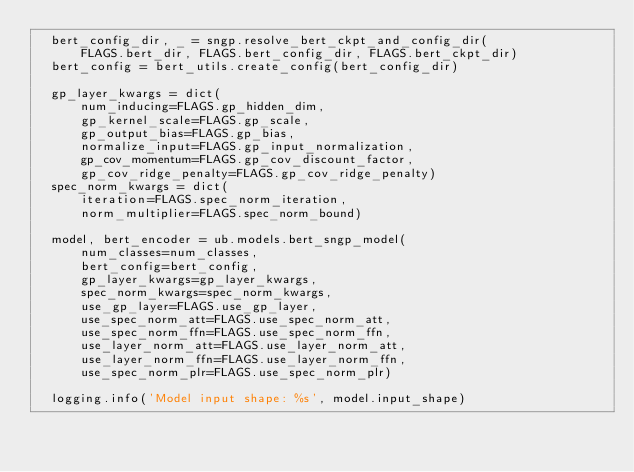Convert code to text. <code><loc_0><loc_0><loc_500><loc_500><_Python_>  bert_config_dir, _ = sngp.resolve_bert_ckpt_and_config_dir(
      FLAGS.bert_dir, FLAGS.bert_config_dir, FLAGS.bert_ckpt_dir)
  bert_config = bert_utils.create_config(bert_config_dir)

  gp_layer_kwargs = dict(
      num_inducing=FLAGS.gp_hidden_dim,
      gp_kernel_scale=FLAGS.gp_scale,
      gp_output_bias=FLAGS.gp_bias,
      normalize_input=FLAGS.gp_input_normalization,
      gp_cov_momentum=FLAGS.gp_cov_discount_factor,
      gp_cov_ridge_penalty=FLAGS.gp_cov_ridge_penalty)
  spec_norm_kwargs = dict(
      iteration=FLAGS.spec_norm_iteration,
      norm_multiplier=FLAGS.spec_norm_bound)

  model, bert_encoder = ub.models.bert_sngp_model(
      num_classes=num_classes,
      bert_config=bert_config,
      gp_layer_kwargs=gp_layer_kwargs,
      spec_norm_kwargs=spec_norm_kwargs,
      use_gp_layer=FLAGS.use_gp_layer,
      use_spec_norm_att=FLAGS.use_spec_norm_att,
      use_spec_norm_ffn=FLAGS.use_spec_norm_ffn,
      use_layer_norm_att=FLAGS.use_layer_norm_att,
      use_layer_norm_ffn=FLAGS.use_layer_norm_ffn,
      use_spec_norm_plr=FLAGS.use_spec_norm_plr)

  logging.info('Model input shape: %s', model.input_shape)</code> 